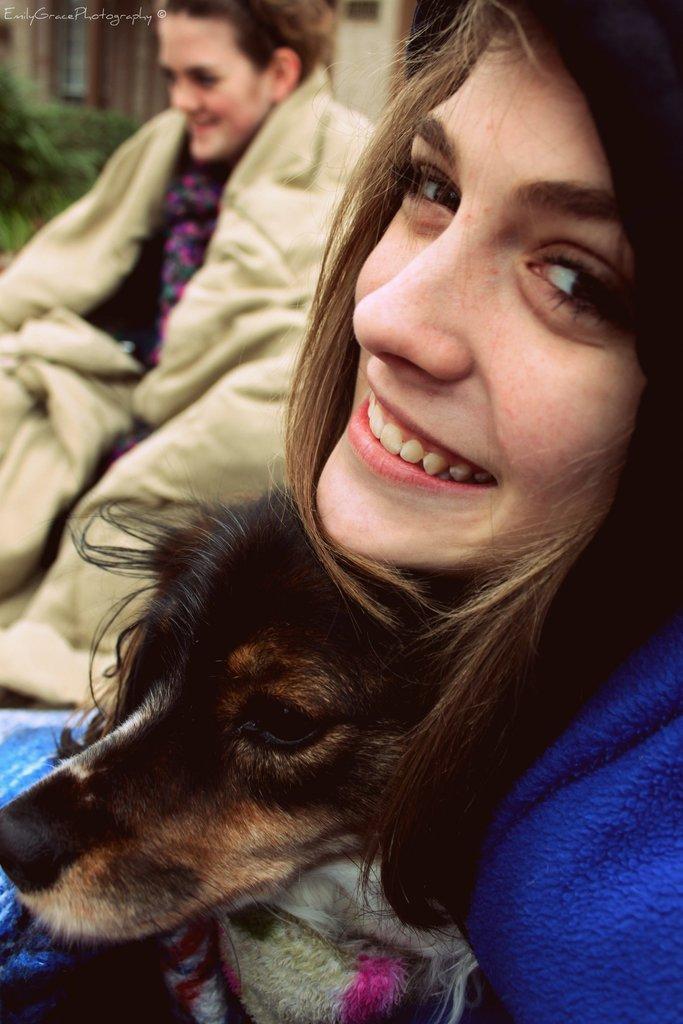Can you describe this image briefly? in this image there are two person they are laughing and one dog is there and the background is morning 